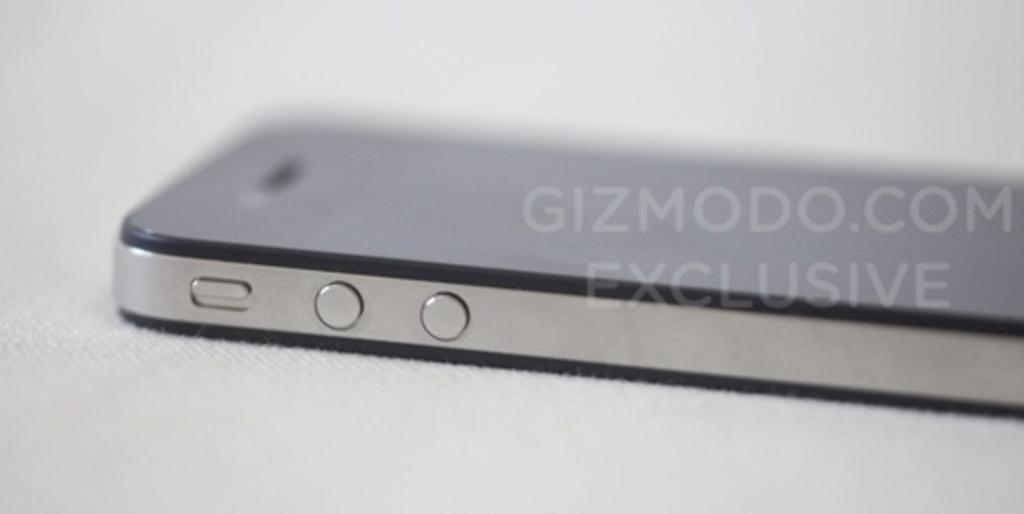<image>
Offer a succinct explanation of the picture presented. The side of a cell phone with a watermark that says gizmodo.com. 